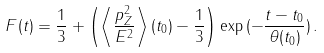Convert formula to latex. <formula><loc_0><loc_0><loc_500><loc_500>F ( t ) = \frac { 1 } { 3 } + \left ( \left < \frac { p _ { Z } ^ { 2 } } { E ^ { 2 } } \right > ( t _ { 0 } ) - \frac { 1 } { 3 } \right ) \exp \, ( - \frac { t - t _ { 0 } } { \theta ( t _ { 0 } ) } ) \, .</formula> 